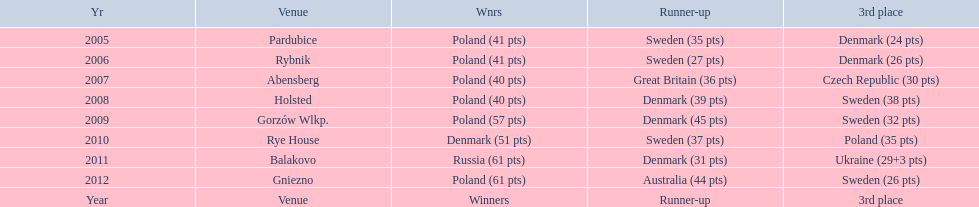In what years did denmark place in the top 3 in the team speedway junior world championship? 2005, 2006, 2008, 2009, 2010, 2011. What in what year did denmark come withing 2 points of placing higher in the standings? 2006. What place did denmark receive the year they missed higher ranking by only 2 points? 3rd place. 